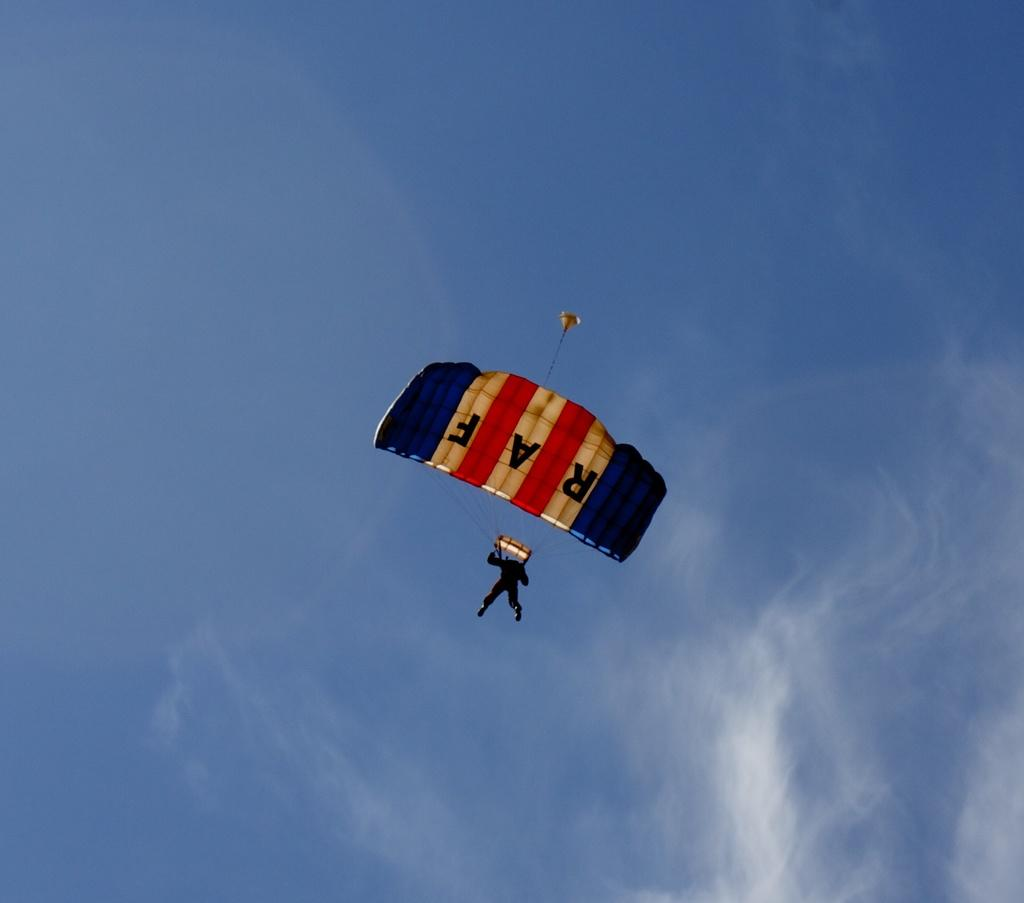<image>
Provide a brief description of the given image. A person floats through the air attached to an RAF parachute. 